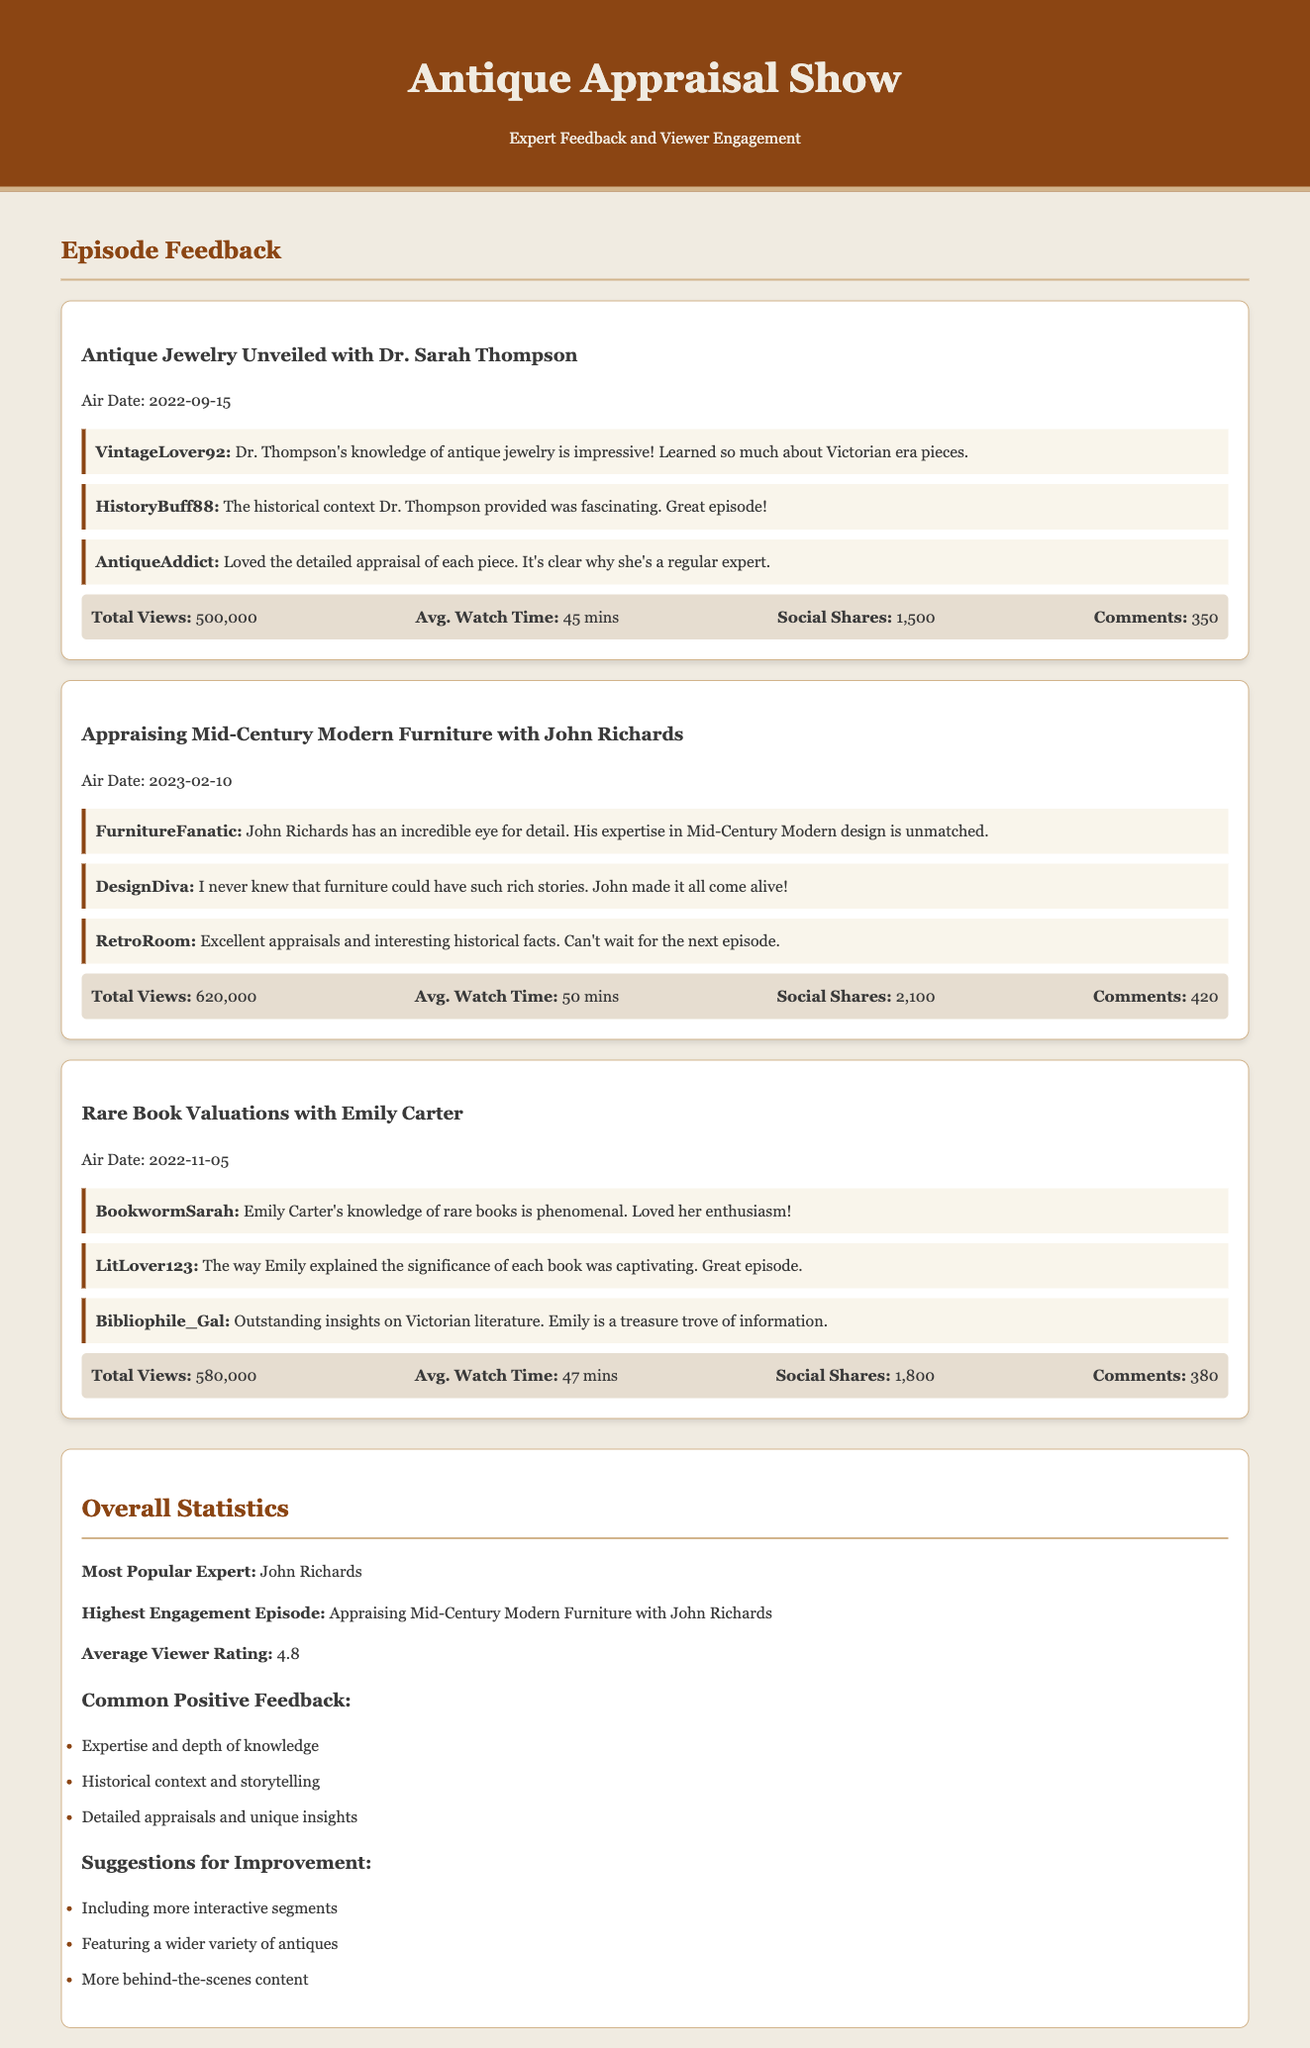What was the air date of the episode featuring Dr. Sarah Thompson? The air date listed for the episode "Antique Jewelry Unveiled with Dr. Sarah Thompson" is September 15, 2022.
Answer: September 15, 2022 How many total views did the episode with John Richards receive? The total views for the episode "Appraising Mid-Century Modern Furniture with John Richards" is stated as 620,000.
Answer: 620,000 Who is noted as the most popular expert in the overall statistics? The document specifies that John Richards is the most popular expert.
Answer: John Richards What is the average viewer rating mentioned in the overall statistics? The overall statistics indicate the average viewer rating is given as 4.8.
Answer: 4.8 Which episode had the highest engagement? The highest engagement episode is identified as "Appraising Mid-Century Modern Furniture with John Richards."
Answer: Appraising Mid-Century Modern Furniture with John Richards What is a common positive feedback noted in the document? The document lists "Expertise and depth of knowledge" as one of the common positive feedback points.
Answer: Expertise and depth of knowledge What is a suggested improvement mentioned in the document? One of the suggestions for improvement is "Including more interactive segments."
Answer: Including more interactive segments What is the average watch time for the episode featuring Emily Carter? The average watch time for "Rare Book Valuations with Emily Carter" is indicated as 47 minutes.
Answer: 47 mins 